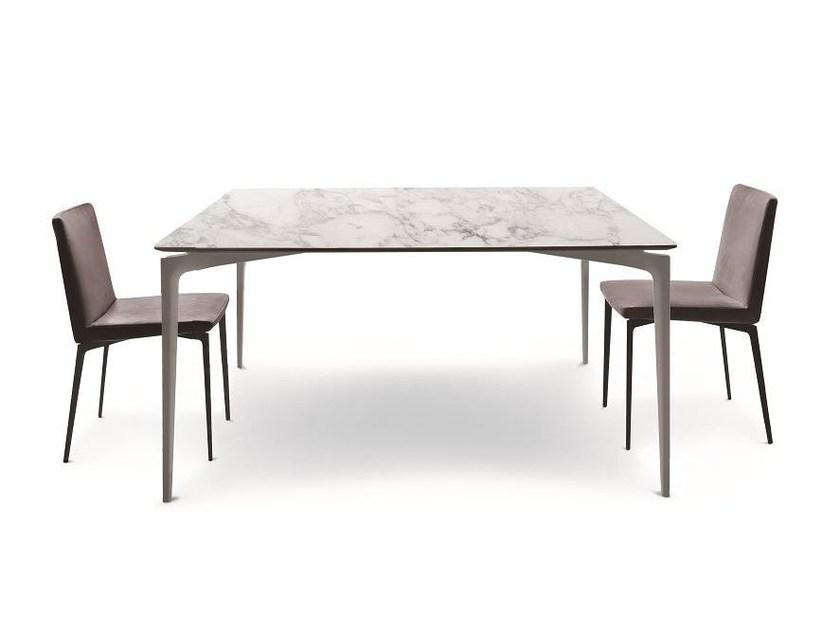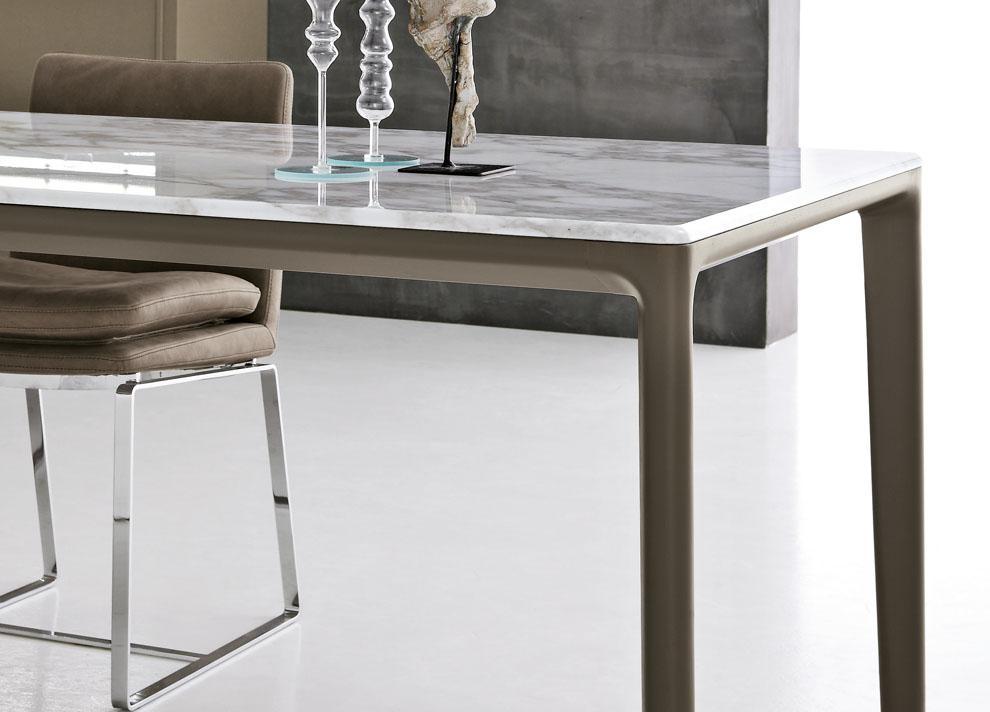The first image is the image on the left, the second image is the image on the right. Analyze the images presented: Is the assertion "A table in one image is round with two chairs." valid? Answer yes or no. No. The first image is the image on the left, the second image is the image on the right. Evaluate the accuracy of this statement regarding the images: "One of the tables is round.". Is it true? Answer yes or no. No. 